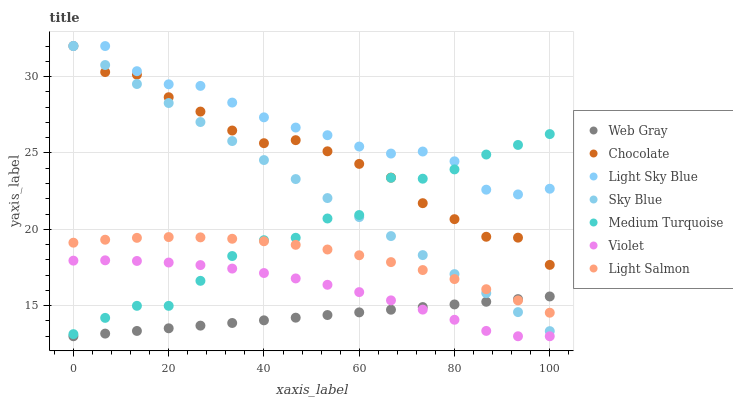Does Web Gray have the minimum area under the curve?
Answer yes or no. Yes. Does Light Sky Blue have the maximum area under the curve?
Answer yes or no. Yes. Does Chocolate have the minimum area under the curve?
Answer yes or no. No. Does Chocolate have the maximum area under the curve?
Answer yes or no. No. Is Web Gray the smoothest?
Answer yes or no. Yes. Is Medium Turquoise the roughest?
Answer yes or no. Yes. Is Chocolate the smoothest?
Answer yes or no. No. Is Chocolate the roughest?
Answer yes or no. No. Does Web Gray have the lowest value?
Answer yes or no. Yes. Does Chocolate have the lowest value?
Answer yes or no. No. Does Sky Blue have the highest value?
Answer yes or no. Yes. Does Web Gray have the highest value?
Answer yes or no. No. Is Web Gray less than Light Sky Blue?
Answer yes or no. Yes. Is Light Salmon greater than Violet?
Answer yes or no. Yes. Does Violet intersect Medium Turquoise?
Answer yes or no. Yes. Is Violet less than Medium Turquoise?
Answer yes or no. No. Is Violet greater than Medium Turquoise?
Answer yes or no. No. Does Web Gray intersect Light Sky Blue?
Answer yes or no. No. 